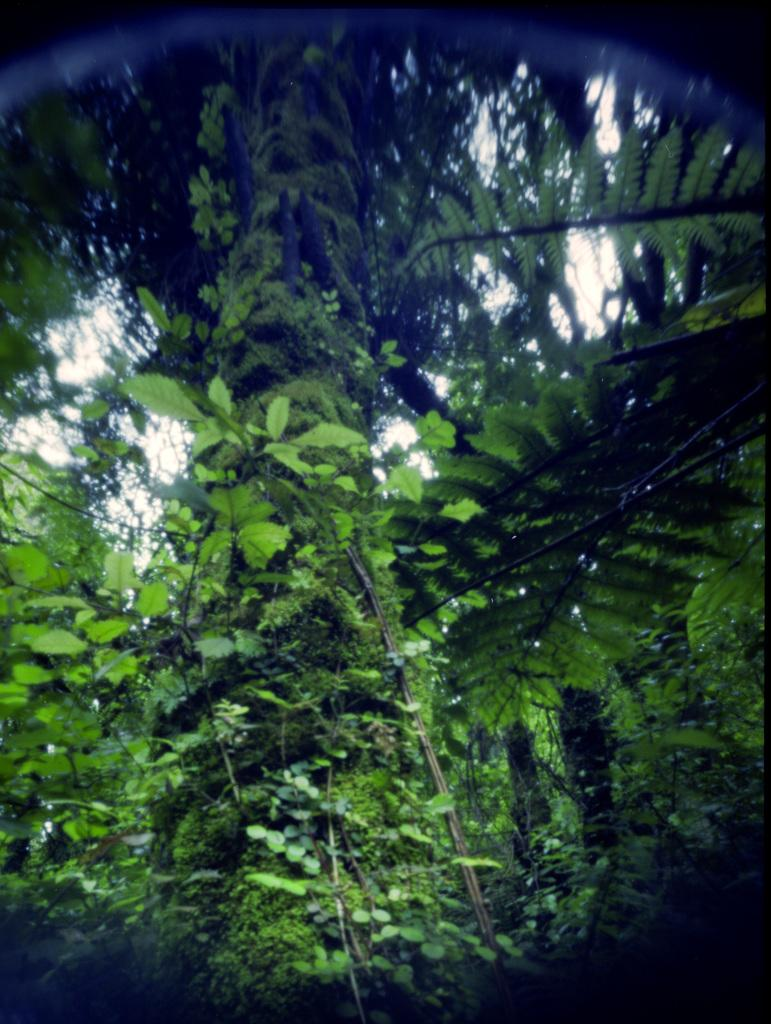What type of vegetation can be seen in the image? There are trees in the image. What part of the natural environment is visible in the image? The sky is visible in the image. What type of church can be seen in the image? There is no church present in the image; it only features trees and the sky. How does the image demonstrate balance? The image does not demonstrate balance as it is a static representation of trees and the sky. 